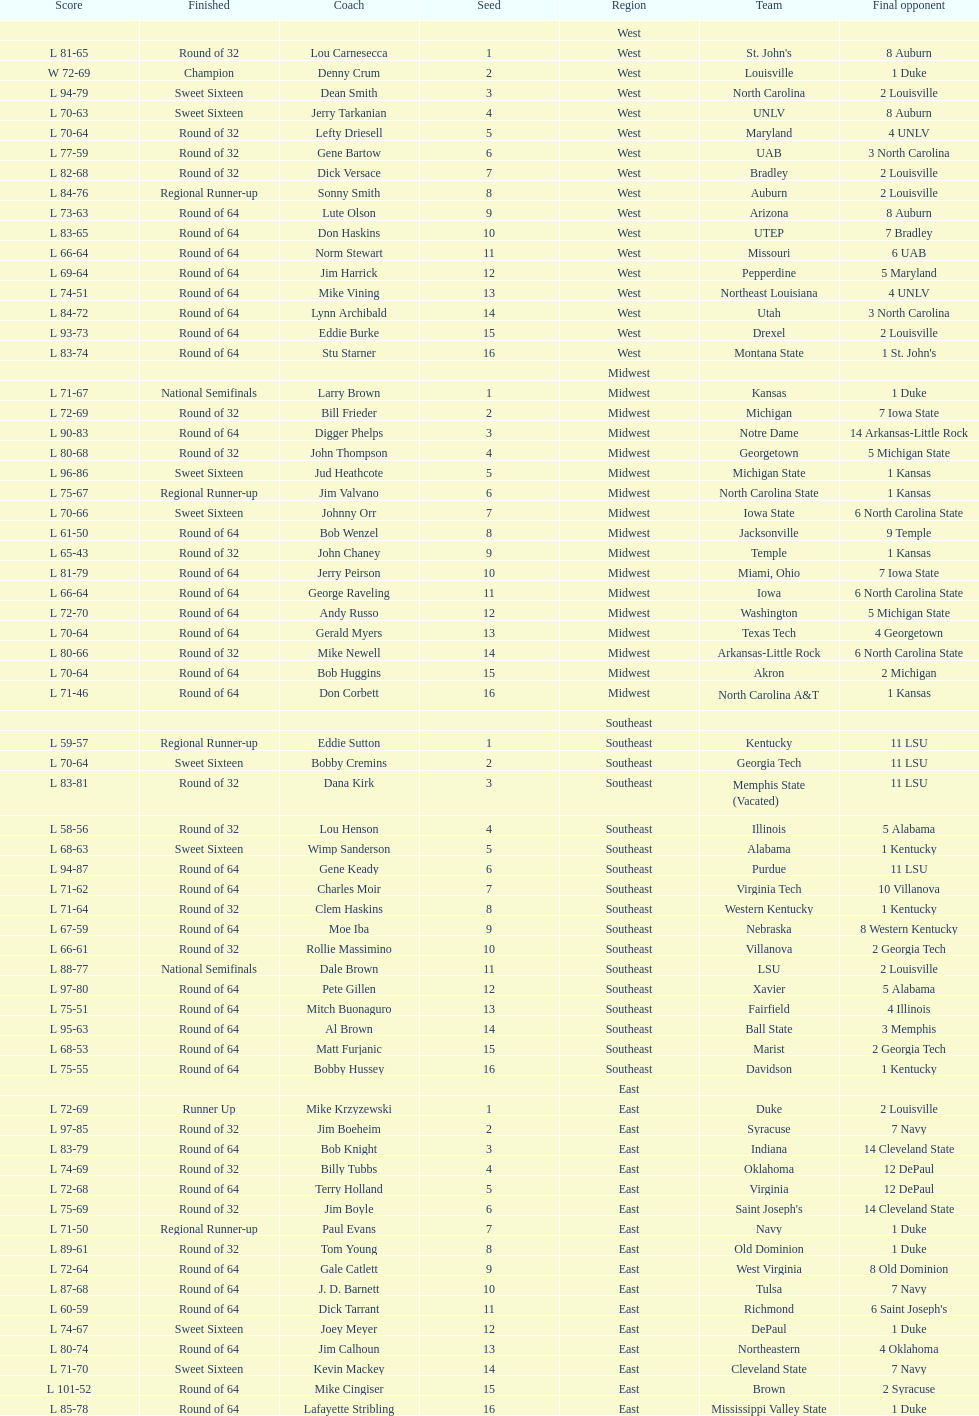What team finished at the top of all else and was finished as champions? Louisville. 